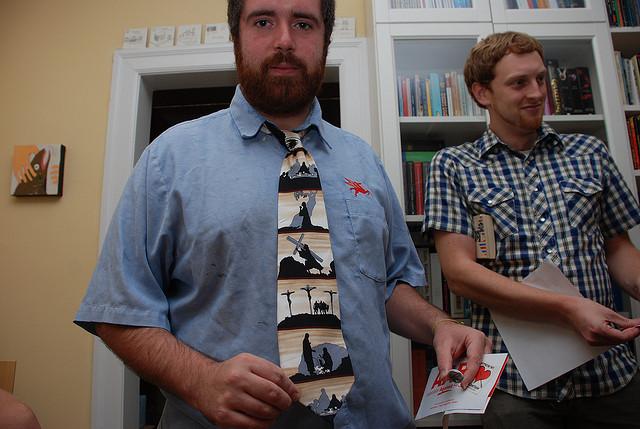Are these men wearing the same shirt?
Keep it brief. No. Does either man have a tie?
Short answer required. Yes. Is the man on the right's collar buttoned?
Answer briefly. No. Are both men looking at the camera?
Short answer required. No. 